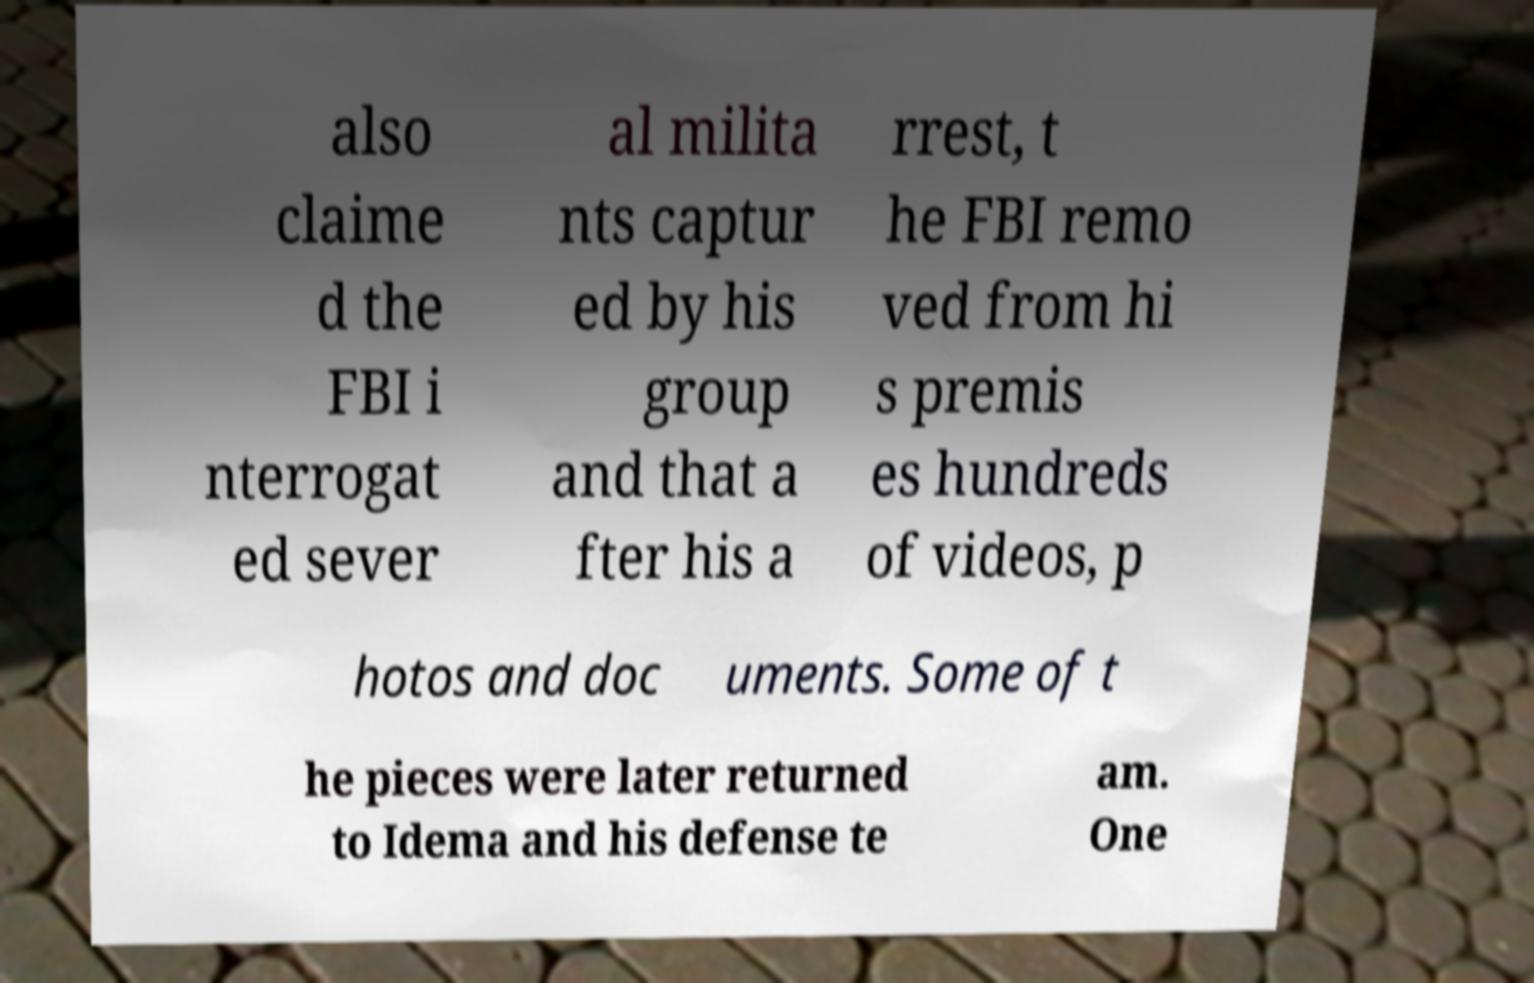Can you accurately transcribe the text from the provided image for me? also claime d the FBI i nterrogat ed sever al milita nts captur ed by his group and that a fter his a rrest, t he FBI remo ved from hi s premis es hundreds of videos, p hotos and doc uments. Some of t he pieces were later returned to Idema and his defense te am. One 